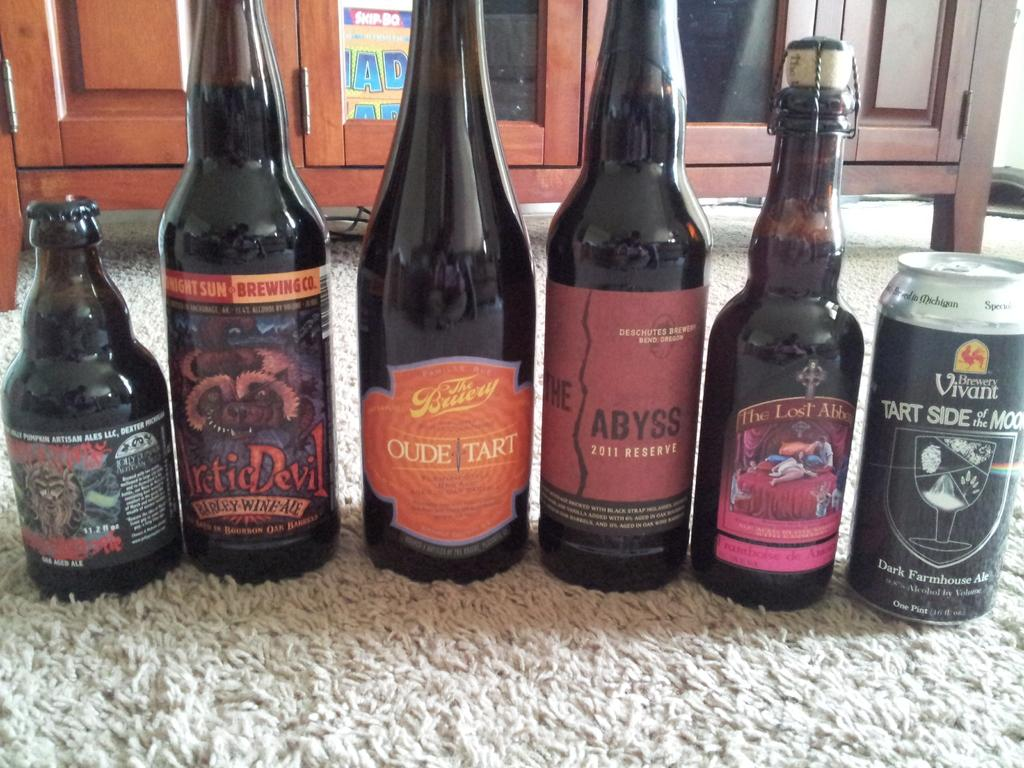What type of containers are visible in the image? There are bottles and a tin in the image. What structure can be seen in the background of the image? There is a cupboard in the background of the image. What surface is visible in the image? The image shows a floor. Can you hear the goose crying in the image? There is no goose present in the image, so it cannot be heard crying. 